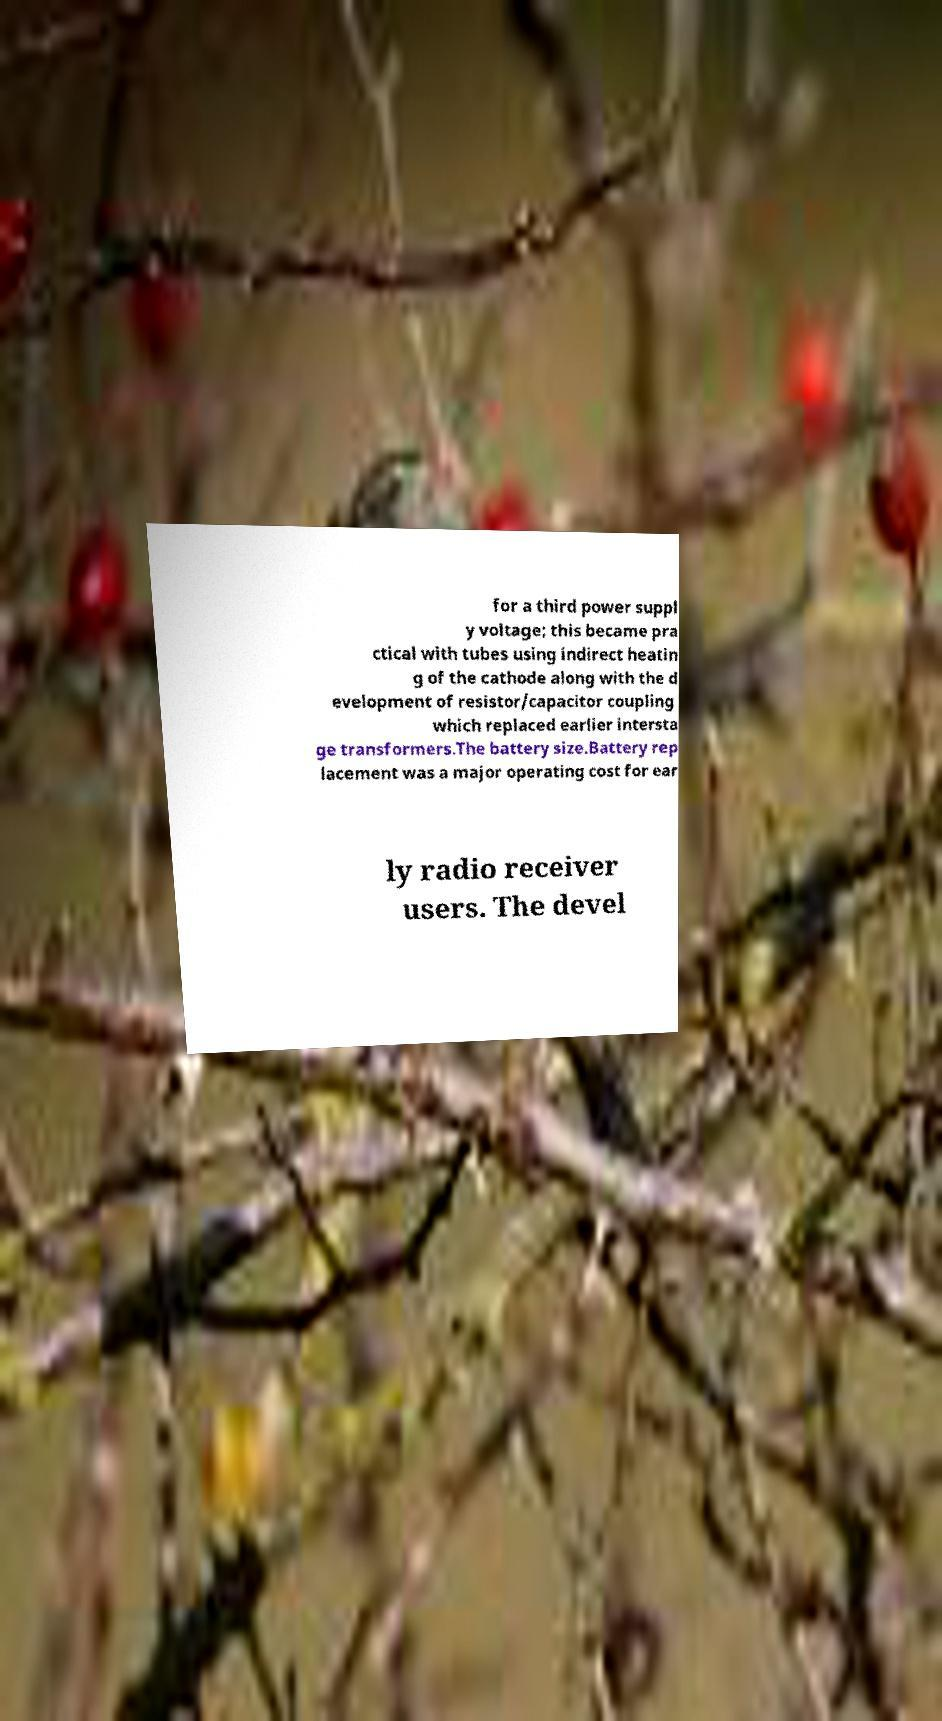Can you read and provide the text displayed in the image?This photo seems to have some interesting text. Can you extract and type it out for me? for a third power suppl y voltage; this became pra ctical with tubes using indirect heatin g of the cathode along with the d evelopment of resistor/capacitor coupling which replaced earlier intersta ge transformers.The battery size.Battery rep lacement was a major operating cost for ear ly radio receiver users. The devel 